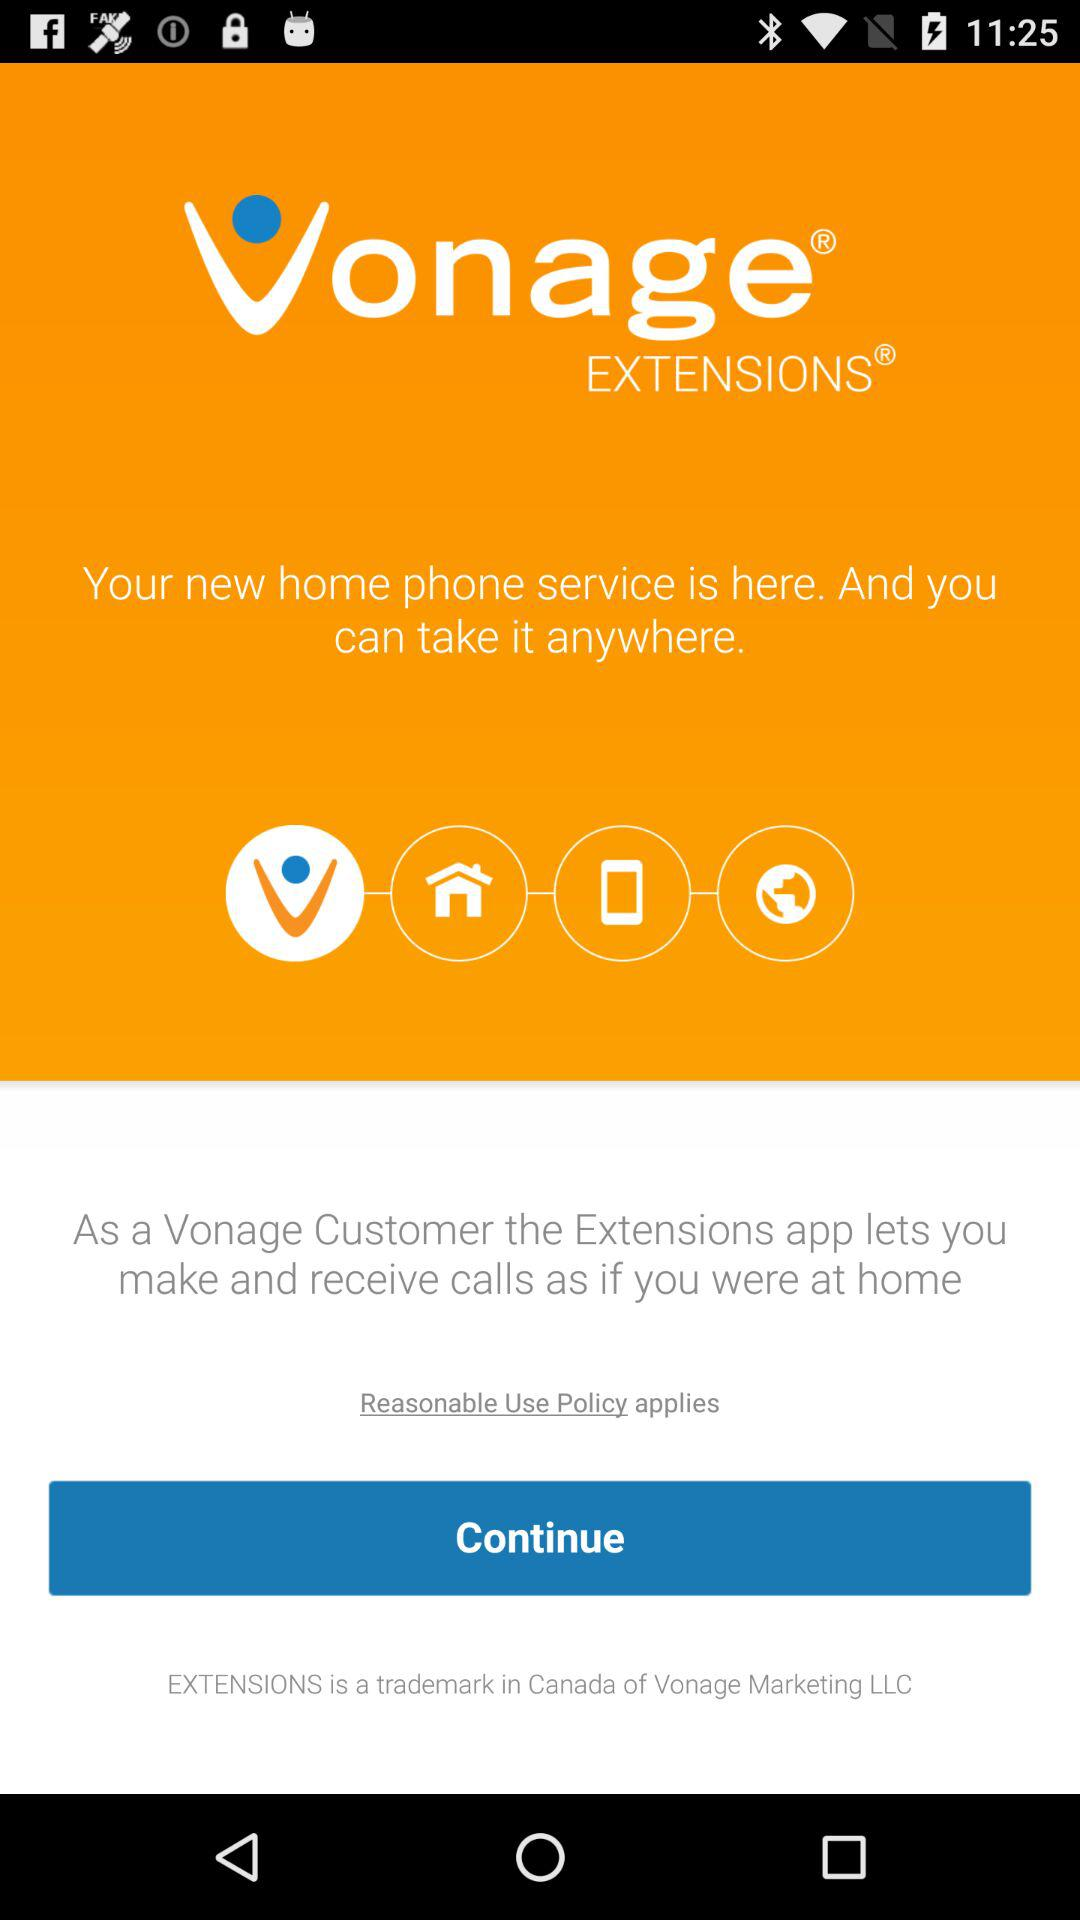What are the advantages of being a "Vonage" customer? The advantage is that the Extensions app lets you make and receive calls as if you were at home. 